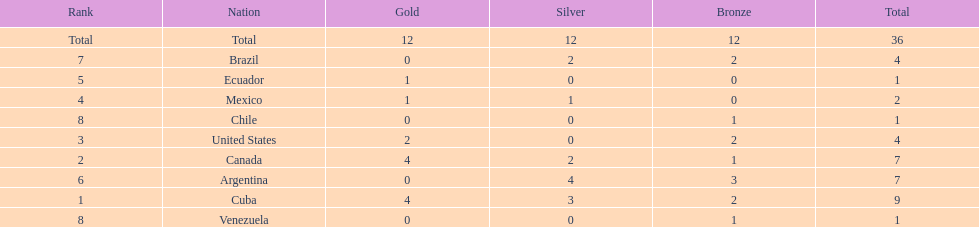Can you parse all the data within this table? {'header': ['Rank', 'Nation', 'Gold', 'Silver', 'Bronze', 'Total'], 'rows': [['Total', 'Total', '12', '12', '12', '36'], ['7', 'Brazil', '0', '2', '2', '4'], ['5', 'Ecuador', '1', '0', '0', '1'], ['4', 'Mexico', '1', '1', '0', '2'], ['8', 'Chile', '0', '0', '1', '1'], ['3', 'United States', '2', '0', '2', '4'], ['2', 'Canada', '4', '2', '1', '7'], ['6', 'Argentina', '0', '4', '3', '7'], ['1', 'Cuba', '4', '3', '2', '9'], ['8', 'Venezuela', '0', '0', '1', '1']]} Which nation won gold but did not win silver? United States. 